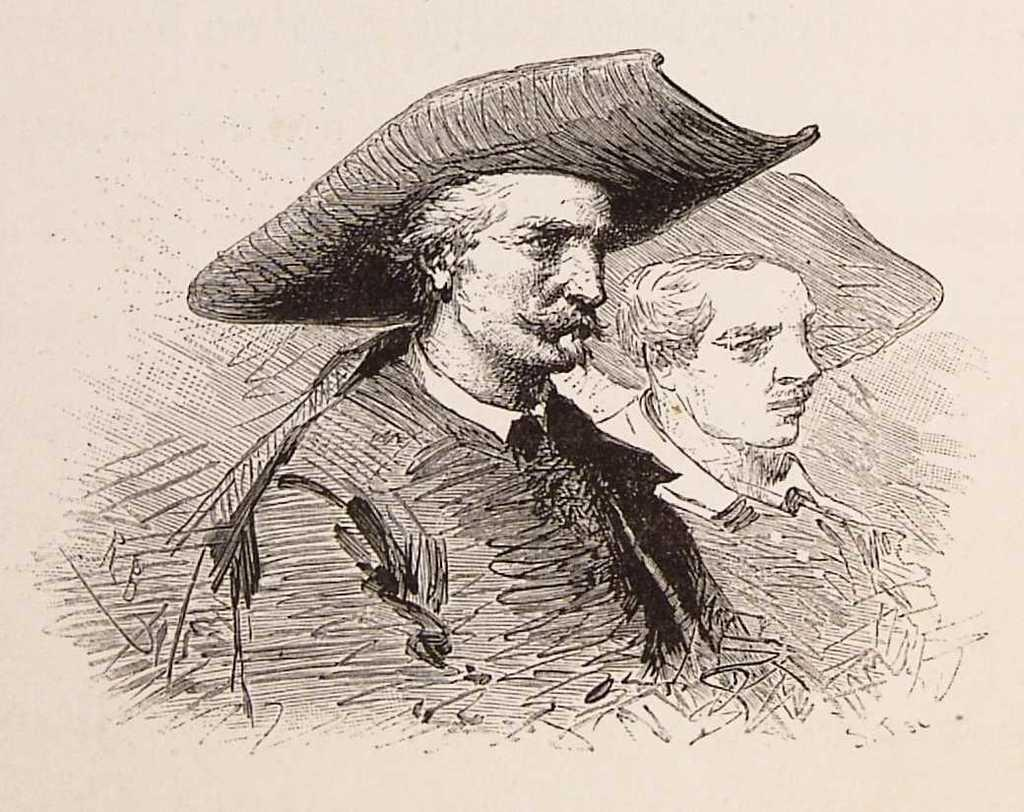What type of image is being described? The image is a drawing. How many people are depicted in the drawing? There are two persons in the drawing. What are the persons wearing in the drawing? The persons are wearing hats. What type of church is visible in the drawing? There is no church present in the drawing; it features two persons wearing hats. How many brothers are depicted in the drawing? The provided facts do not mention anything about the relationship between the two persons in the drawing, so it cannot be determined if they are brothers. 